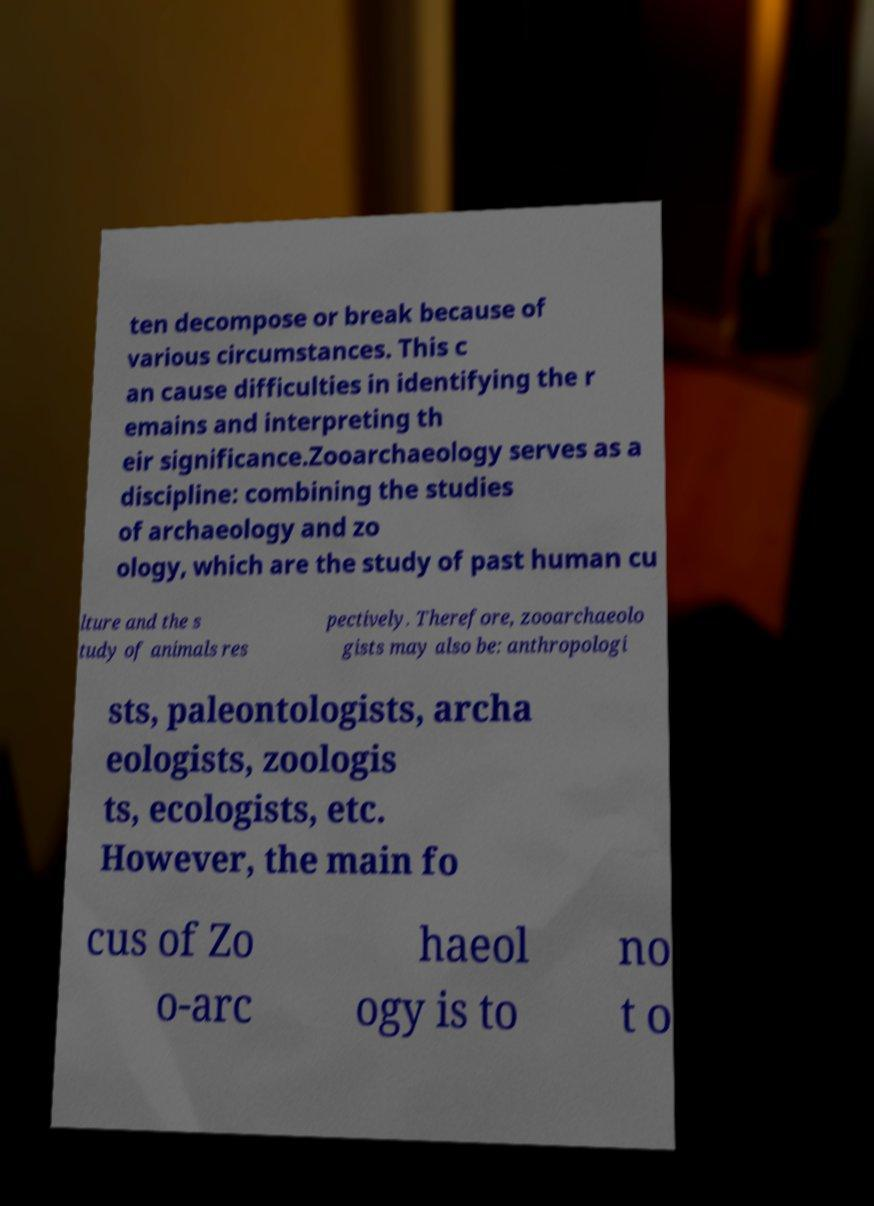Please read and relay the text visible in this image. What does it say? ten decompose or break because of various circumstances. This c an cause difficulties in identifying the r emains and interpreting th eir significance.Zooarchaeology serves as a discipline: combining the studies of archaeology and zo ology, which are the study of past human cu lture and the s tudy of animals res pectively. Therefore, zooarchaeolo gists may also be: anthropologi sts, paleontologists, archa eologists, zoologis ts, ecologists, etc. However, the main fo cus of Zo o-arc haeol ogy is to no t o 